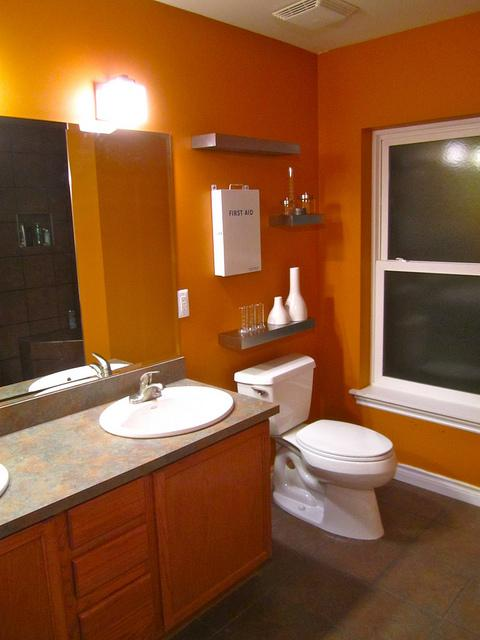What is the toilet near?

Choices:
A) baby
B) kitten
C) poster
D) window window 